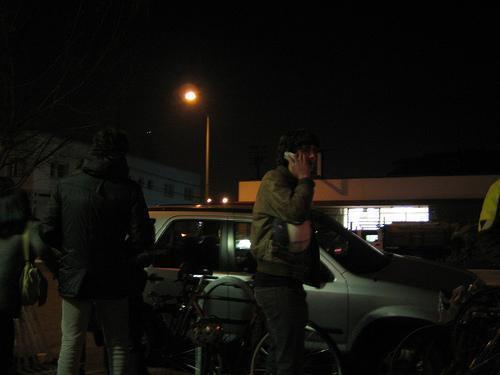How many people are visible?
Give a very brief answer. 3. How many bicycles are there?
Give a very brief answer. 2. How many elephants are there in total?
Give a very brief answer. 0. 